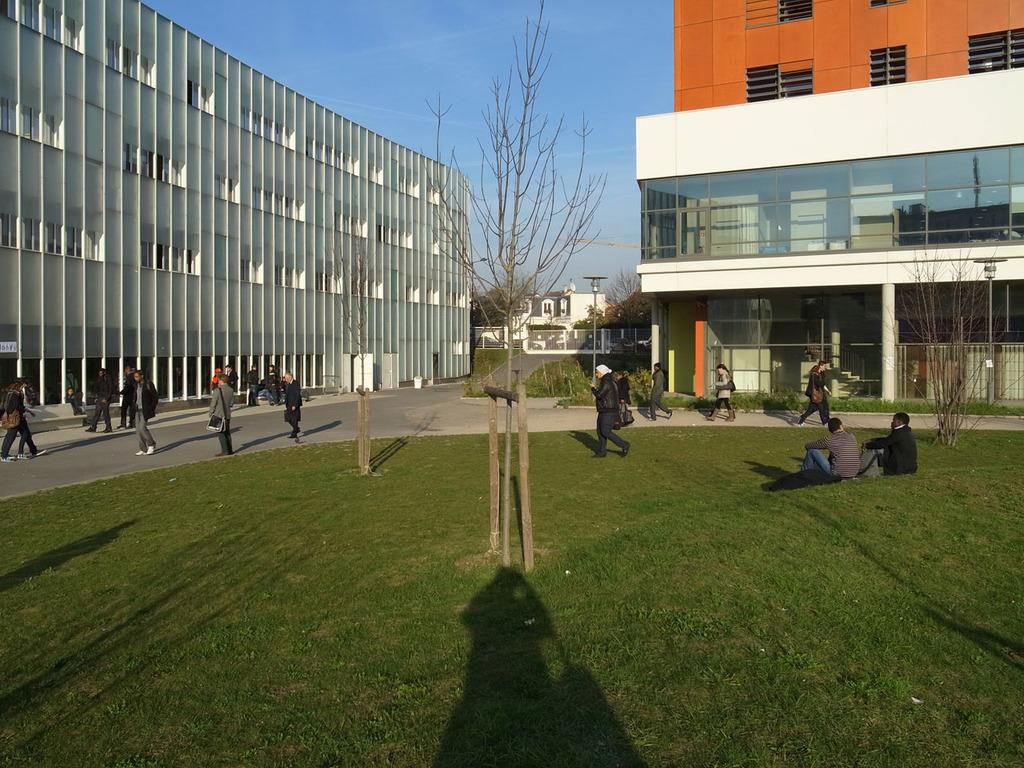What can be seen in the background of the image? There are buildings and the sky visible in the background of the image. What is at the bottom of the image? There is grass at the bottom of the image. What are the people in the image doing? People are walking on the road in the image. What is located in the center of the image? There is a tree in the center of the image. How are the plants being sorted in the image? There are no plants mentioned in the image, and therefore no sorting activity can be observed. What type of patch is visible on the tree in the image? There is no patch visible on the tree in the image; it is a regular tree. 